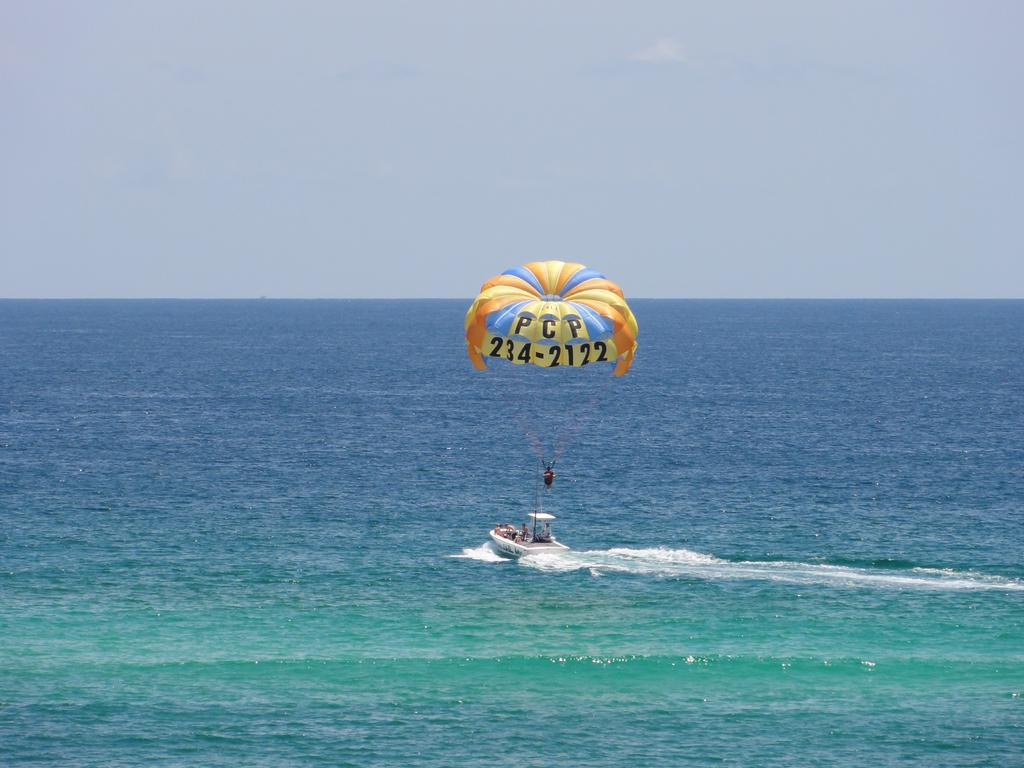What is the main object in the center of the image? There is a parachute in the center of the image. What can be seen in the water in the image? There is a boat in the water. What part of the natural environment is visible in the image? The sky is visible in the background of the image. What type of plantation can be seen in the image? There is no plantation present in the image. 